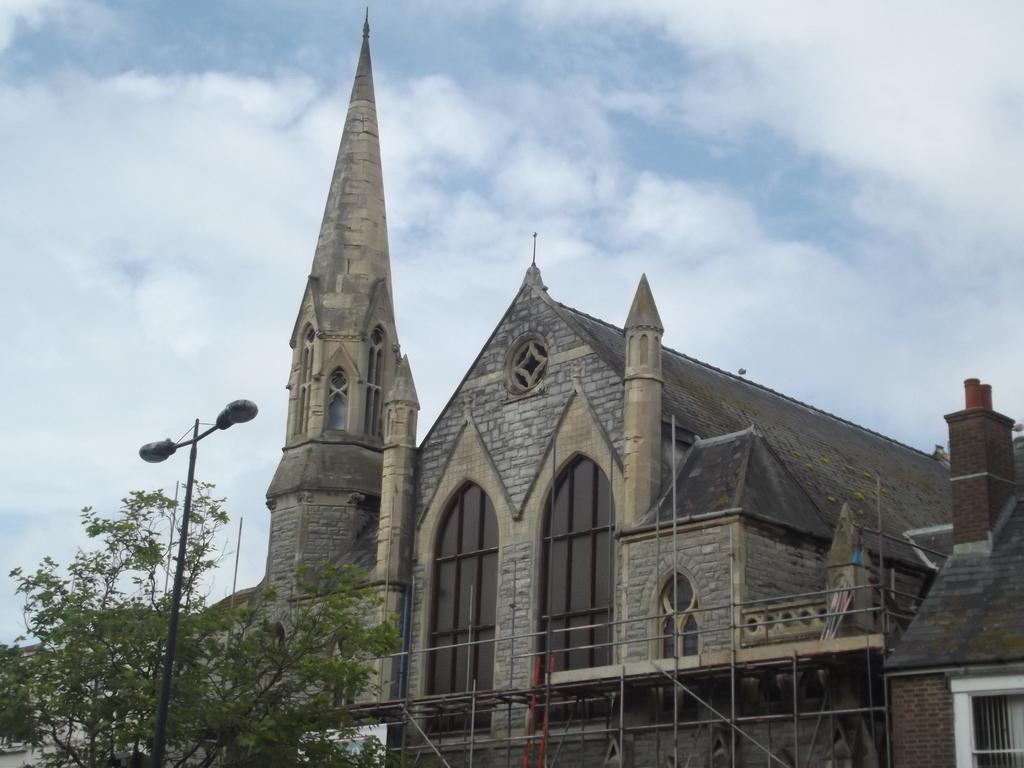What type of structure is visible in the image? There is a building in the image. What is located in front of the building? There is a tree and a pole with a street light in front of the building. What can be seen in the background of the image? The sky is visible in the background of the image. What type of texture can be seen on the tree in the image? There is no specific texture mentioned or visible in the image; we can only see the tree's general shape and location. 